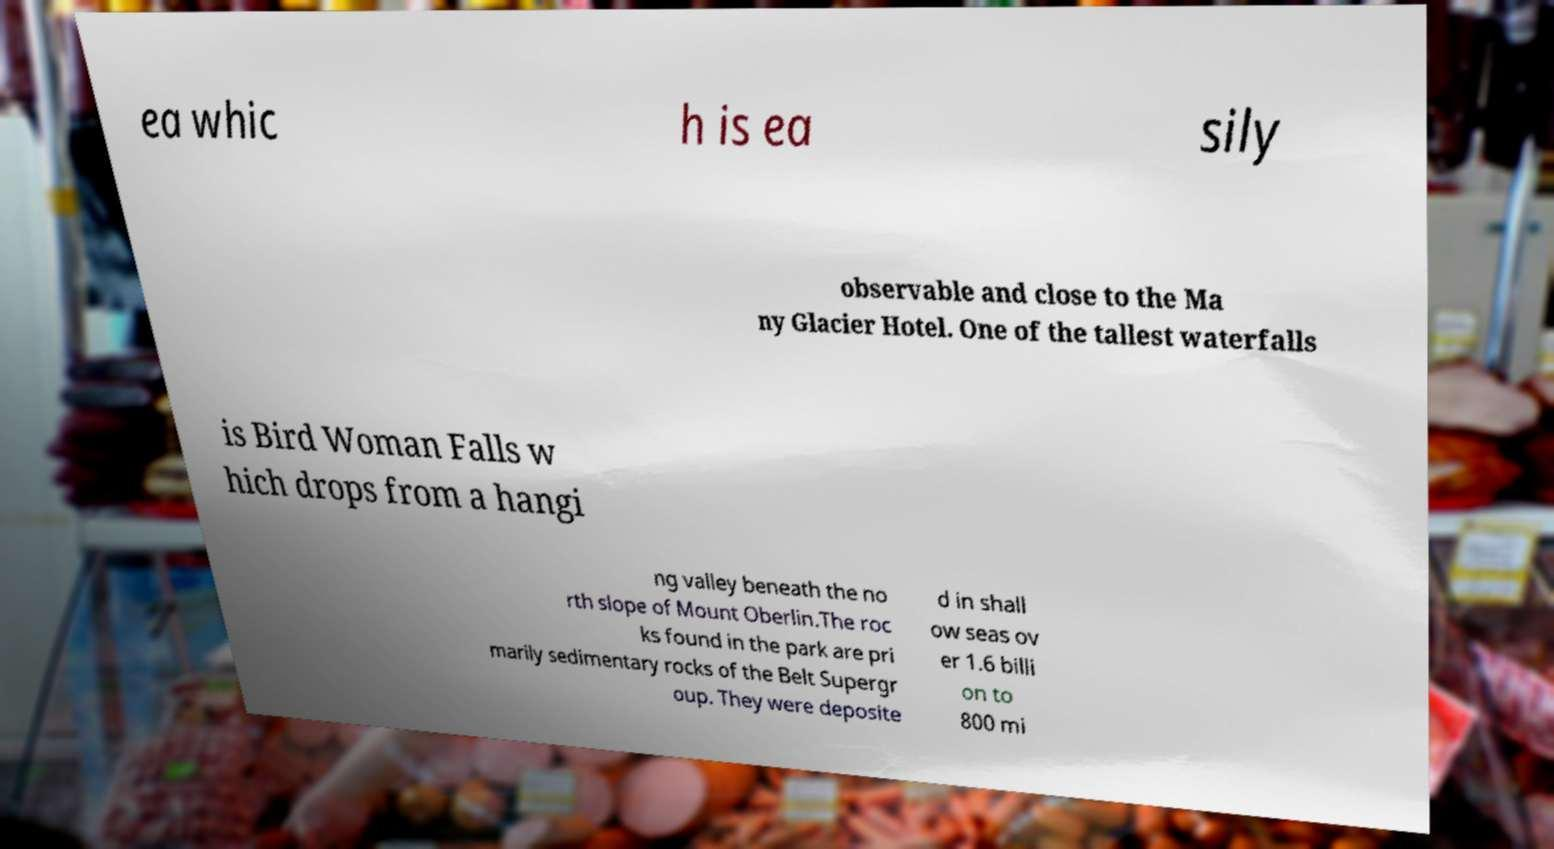I need the written content from this picture converted into text. Can you do that? ea whic h is ea sily observable and close to the Ma ny Glacier Hotel. One of the tallest waterfalls is Bird Woman Falls w hich drops from a hangi ng valley beneath the no rth slope of Mount Oberlin.The roc ks found in the park are pri marily sedimentary rocks of the Belt Supergr oup. They were deposite d in shall ow seas ov er 1.6 billi on to 800 mi 